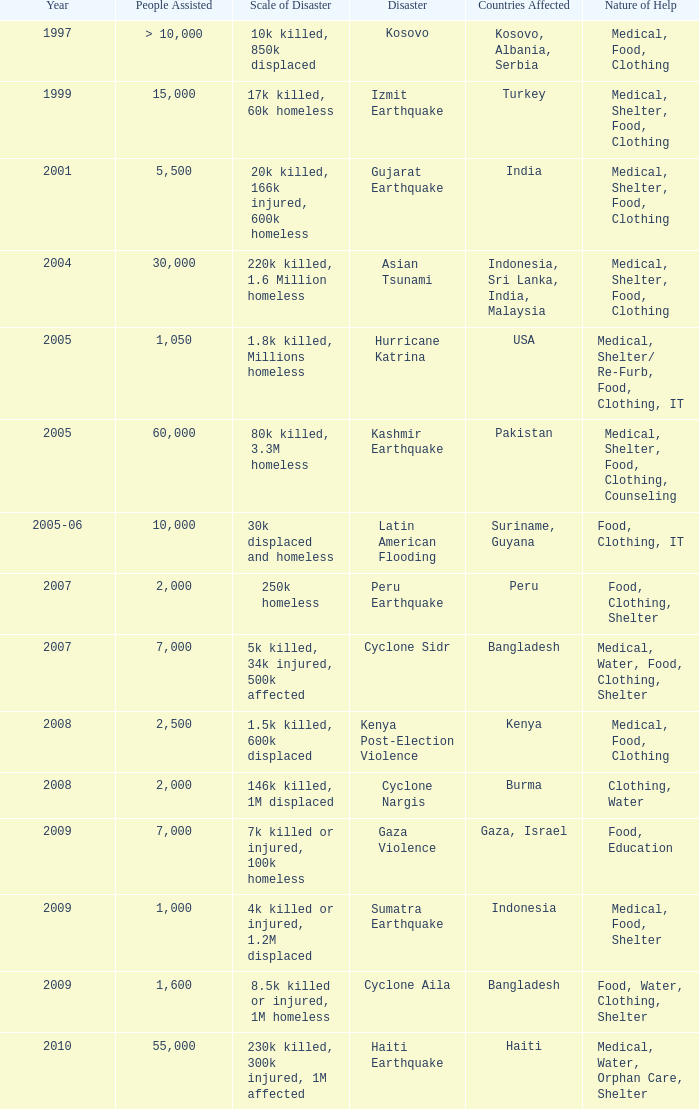In the disaster in which 1,000 people were helped, what was the nature of help? Medical, Food, Shelter. 